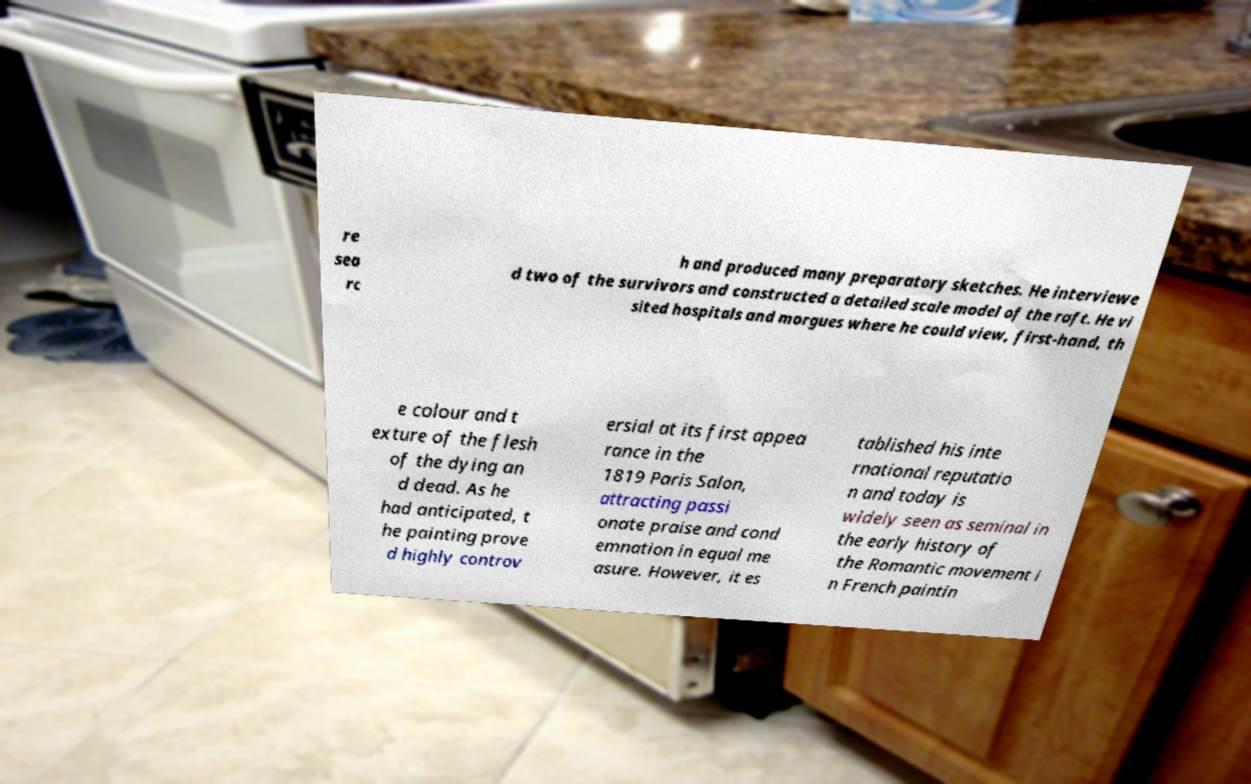Please identify and transcribe the text found in this image. re sea rc h and produced many preparatory sketches. He interviewe d two of the survivors and constructed a detailed scale model of the raft. He vi sited hospitals and morgues where he could view, first-hand, th e colour and t exture of the flesh of the dying an d dead. As he had anticipated, t he painting prove d highly controv ersial at its first appea rance in the 1819 Paris Salon, attracting passi onate praise and cond emnation in equal me asure. However, it es tablished his inte rnational reputatio n and today is widely seen as seminal in the early history of the Romantic movement i n French paintin 